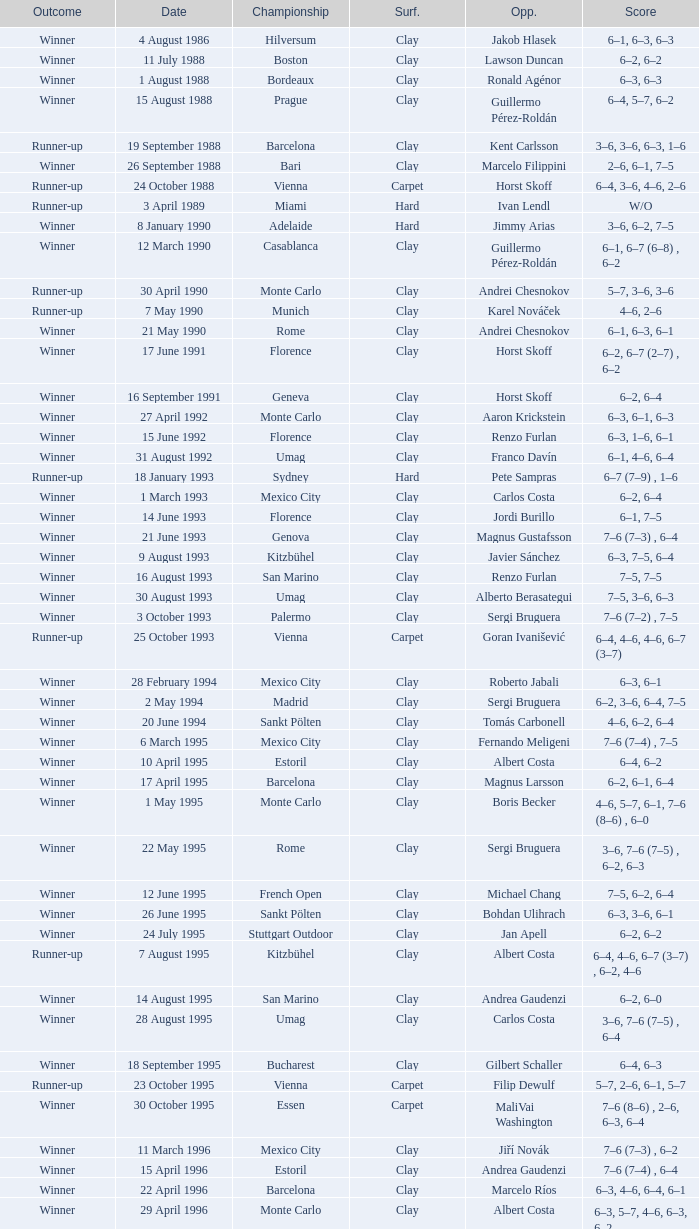What is the score when the outcome is winner against yevgeny kafelnikov? 6–2, 6–2, 6–4. 